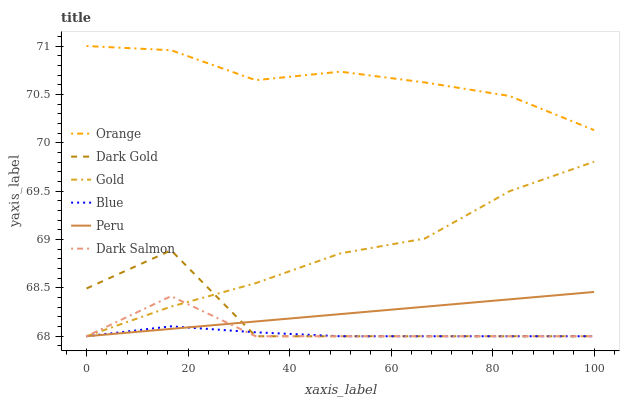Does Gold have the minimum area under the curve?
Answer yes or no. No. Does Gold have the maximum area under the curve?
Answer yes or no. No. Is Gold the smoothest?
Answer yes or no. No. Is Gold the roughest?
Answer yes or no. No. Does Orange have the lowest value?
Answer yes or no. No. Does Gold have the highest value?
Answer yes or no. No. Is Dark Salmon less than Orange?
Answer yes or no. Yes. Is Orange greater than Peru?
Answer yes or no. Yes. Does Dark Salmon intersect Orange?
Answer yes or no. No. 